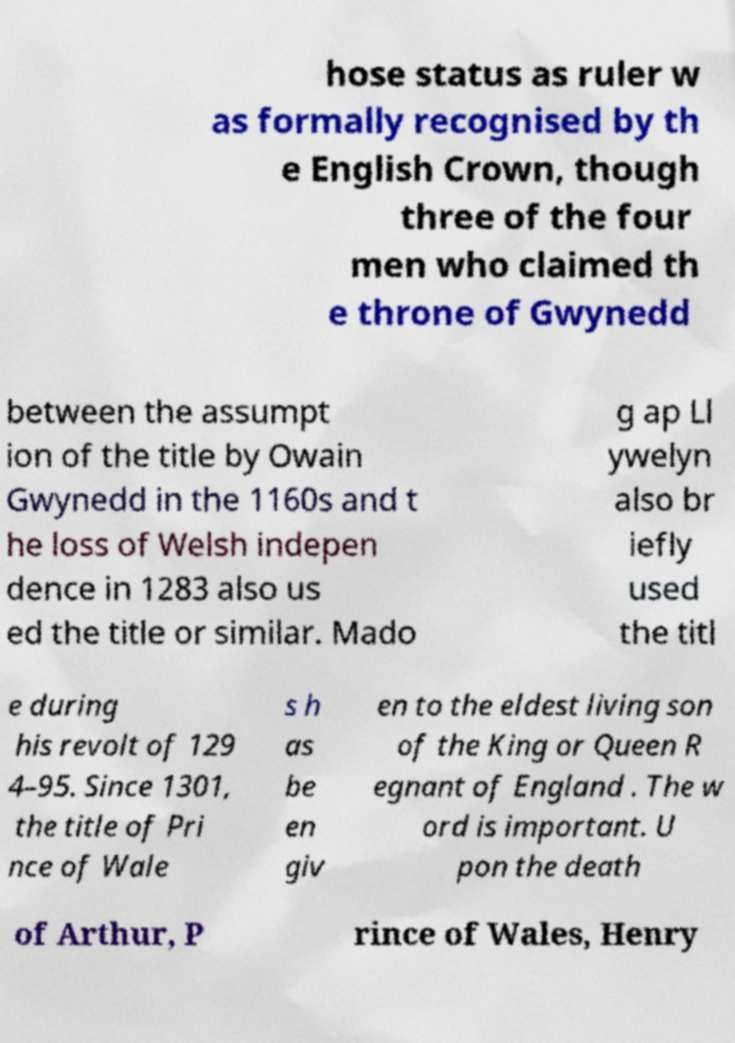Can you accurately transcribe the text from the provided image for me? hose status as ruler w as formally recognised by th e English Crown, though three of the four men who claimed th e throne of Gwynedd between the assumpt ion of the title by Owain Gwynedd in the 1160s and t he loss of Welsh indepen dence in 1283 also us ed the title or similar. Mado g ap Ll ywelyn also br iefly used the titl e during his revolt of 129 4–95. Since 1301, the title of Pri nce of Wale s h as be en giv en to the eldest living son of the King or Queen R egnant of England . The w ord is important. U pon the death of Arthur, P rince of Wales, Henry 